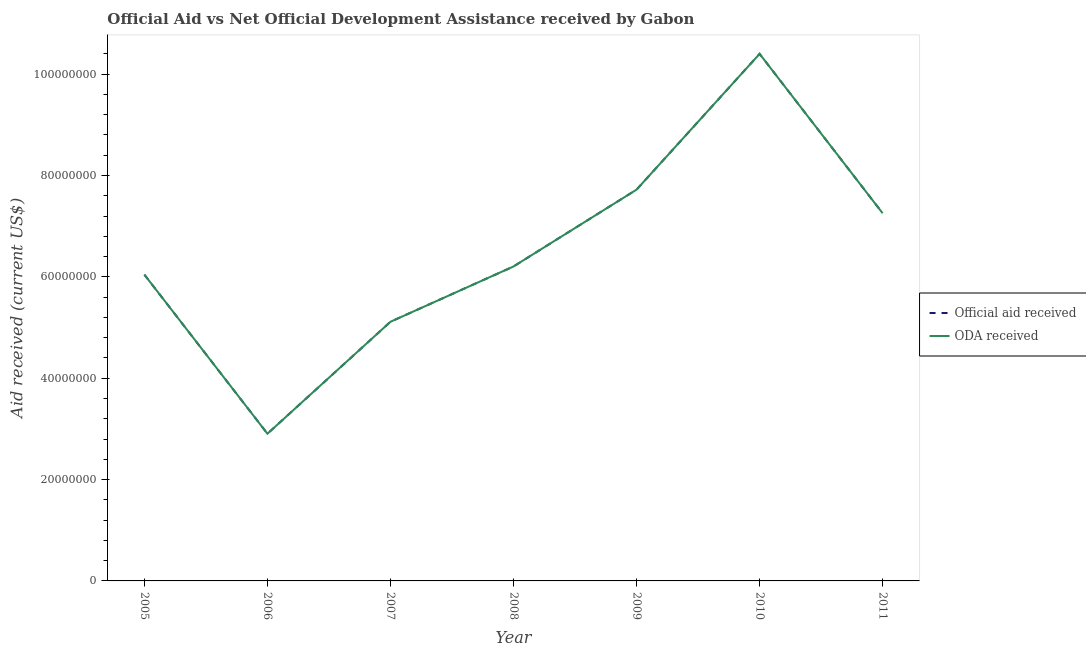How many different coloured lines are there?
Your answer should be compact. 2. Is the number of lines equal to the number of legend labels?
Your response must be concise. Yes. What is the oda received in 2006?
Make the answer very short. 2.90e+07. Across all years, what is the maximum official aid received?
Your answer should be very brief. 1.04e+08. Across all years, what is the minimum oda received?
Provide a succinct answer. 2.90e+07. What is the total oda received in the graph?
Keep it short and to the point. 4.56e+08. What is the difference between the oda received in 2006 and that in 2010?
Provide a short and direct response. -7.50e+07. What is the difference between the official aid received in 2010 and the oda received in 2008?
Your answer should be very brief. 4.20e+07. What is the average oda received per year?
Your answer should be compact. 6.52e+07. In the year 2005, what is the difference between the oda received and official aid received?
Ensure brevity in your answer.  0. In how many years, is the oda received greater than 32000000 US$?
Your answer should be compact. 6. What is the ratio of the oda received in 2005 to that in 2007?
Provide a short and direct response. 1.18. What is the difference between the highest and the second highest oda received?
Your answer should be compact. 2.68e+07. What is the difference between the highest and the lowest oda received?
Give a very brief answer. 7.50e+07. In how many years, is the official aid received greater than the average official aid received taken over all years?
Your answer should be very brief. 3. Is the official aid received strictly greater than the oda received over the years?
Your response must be concise. No. Is the official aid received strictly less than the oda received over the years?
Offer a very short reply. No. How many years are there in the graph?
Offer a terse response. 7. Are the values on the major ticks of Y-axis written in scientific E-notation?
Ensure brevity in your answer.  No. Does the graph contain any zero values?
Keep it short and to the point. No. How are the legend labels stacked?
Your response must be concise. Vertical. What is the title of the graph?
Provide a short and direct response. Official Aid vs Net Official Development Assistance received by Gabon . What is the label or title of the X-axis?
Your response must be concise. Year. What is the label or title of the Y-axis?
Provide a short and direct response. Aid received (current US$). What is the Aid received (current US$) in Official aid received in 2005?
Offer a very short reply. 6.04e+07. What is the Aid received (current US$) of ODA received in 2005?
Provide a short and direct response. 6.04e+07. What is the Aid received (current US$) of Official aid received in 2006?
Give a very brief answer. 2.90e+07. What is the Aid received (current US$) of ODA received in 2006?
Make the answer very short. 2.90e+07. What is the Aid received (current US$) of Official aid received in 2007?
Keep it short and to the point. 5.11e+07. What is the Aid received (current US$) of ODA received in 2007?
Offer a terse response. 5.11e+07. What is the Aid received (current US$) in Official aid received in 2008?
Ensure brevity in your answer.  6.20e+07. What is the Aid received (current US$) in ODA received in 2008?
Your response must be concise. 6.20e+07. What is the Aid received (current US$) of Official aid received in 2009?
Give a very brief answer. 7.72e+07. What is the Aid received (current US$) in ODA received in 2009?
Ensure brevity in your answer.  7.72e+07. What is the Aid received (current US$) of Official aid received in 2010?
Ensure brevity in your answer.  1.04e+08. What is the Aid received (current US$) in ODA received in 2010?
Provide a succinct answer. 1.04e+08. What is the Aid received (current US$) of Official aid received in 2011?
Provide a short and direct response. 7.26e+07. What is the Aid received (current US$) of ODA received in 2011?
Offer a very short reply. 7.26e+07. Across all years, what is the maximum Aid received (current US$) in Official aid received?
Offer a very short reply. 1.04e+08. Across all years, what is the maximum Aid received (current US$) of ODA received?
Your answer should be very brief. 1.04e+08. Across all years, what is the minimum Aid received (current US$) of Official aid received?
Offer a terse response. 2.90e+07. Across all years, what is the minimum Aid received (current US$) in ODA received?
Your answer should be very brief. 2.90e+07. What is the total Aid received (current US$) of Official aid received in the graph?
Your answer should be compact. 4.56e+08. What is the total Aid received (current US$) in ODA received in the graph?
Offer a very short reply. 4.56e+08. What is the difference between the Aid received (current US$) in Official aid received in 2005 and that in 2006?
Provide a short and direct response. 3.14e+07. What is the difference between the Aid received (current US$) in ODA received in 2005 and that in 2006?
Your answer should be compact. 3.14e+07. What is the difference between the Aid received (current US$) in Official aid received in 2005 and that in 2007?
Offer a terse response. 9.29e+06. What is the difference between the Aid received (current US$) in ODA received in 2005 and that in 2007?
Ensure brevity in your answer.  9.29e+06. What is the difference between the Aid received (current US$) of Official aid received in 2005 and that in 2008?
Your answer should be compact. -1.62e+06. What is the difference between the Aid received (current US$) in ODA received in 2005 and that in 2008?
Offer a very short reply. -1.62e+06. What is the difference between the Aid received (current US$) of Official aid received in 2005 and that in 2009?
Provide a short and direct response. -1.68e+07. What is the difference between the Aid received (current US$) in ODA received in 2005 and that in 2009?
Provide a succinct answer. -1.68e+07. What is the difference between the Aid received (current US$) in Official aid received in 2005 and that in 2010?
Provide a succinct answer. -4.36e+07. What is the difference between the Aid received (current US$) in ODA received in 2005 and that in 2010?
Keep it short and to the point. -4.36e+07. What is the difference between the Aid received (current US$) of Official aid received in 2005 and that in 2011?
Keep it short and to the point. -1.21e+07. What is the difference between the Aid received (current US$) in ODA received in 2005 and that in 2011?
Ensure brevity in your answer.  -1.21e+07. What is the difference between the Aid received (current US$) of Official aid received in 2006 and that in 2007?
Keep it short and to the point. -2.21e+07. What is the difference between the Aid received (current US$) in ODA received in 2006 and that in 2007?
Offer a terse response. -2.21e+07. What is the difference between the Aid received (current US$) of Official aid received in 2006 and that in 2008?
Ensure brevity in your answer.  -3.30e+07. What is the difference between the Aid received (current US$) of ODA received in 2006 and that in 2008?
Make the answer very short. -3.30e+07. What is the difference between the Aid received (current US$) of Official aid received in 2006 and that in 2009?
Your answer should be very brief. -4.82e+07. What is the difference between the Aid received (current US$) of ODA received in 2006 and that in 2009?
Ensure brevity in your answer.  -4.82e+07. What is the difference between the Aid received (current US$) of Official aid received in 2006 and that in 2010?
Your answer should be very brief. -7.50e+07. What is the difference between the Aid received (current US$) in ODA received in 2006 and that in 2010?
Give a very brief answer. -7.50e+07. What is the difference between the Aid received (current US$) in Official aid received in 2006 and that in 2011?
Give a very brief answer. -4.35e+07. What is the difference between the Aid received (current US$) of ODA received in 2006 and that in 2011?
Give a very brief answer. -4.35e+07. What is the difference between the Aid received (current US$) in Official aid received in 2007 and that in 2008?
Make the answer very short. -1.09e+07. What is the difference between the Aid received (current US$) in ODA received in 2007 and that in 2008?
Offer a terse response. -1.09e+07. What is the difference between the Aid received (current US$) in Official aid received in 2007 and that in 2009?
Keep it short and to the point. -2.61e+07. What is the difference between the Aid received (current US$) in ODA received in 2007 and that in 2009?
Your response must be concise. -2.61e+07. What is the difference between the Aid received (current US$) in Official aid received in 2007 and that in 2010?
Offer a very short reply. -5.29e+07. What is the difference between the Aid received (current US$) of ODA received in 2007 and that in 2010?
Make the answer very short. -5.29e+07. What is the difference between the Aid received (current US$) in Official aid received in 2007 and that in 2011?
Give a very brief answer. -2.14e+07. What is the difference between the Aid received (current US$) of ODA received in 2007 and that in 2011?
Make the answer very short. -2.14e+07. What is the difference between the Aid received (current US$) in Official aid received in 2008 and that in 2009?
Provide a short and direct response. -1.52e+07. What is the difference between the Aid received (current US$) of ODA received in 2008 and that in 2009?
Provide a short and direct response. -1.52e+07. What is the difference between the Aid received (current US$) of Official aid received in 2008 and that in 2010?
Offer a very short reply. -4.20e+07. What is the difference between the Aid received (current US$) of ODA received in 2008 and that in 2010?
Your answer should be compact. -4.20e+07. What is the difference between the Aid received (current US$) of Official aid received in 2008 and that in 2011?
Your answer should be very brief. -1.05e+07. What is the difference between the Aid received (current US$) in ODA received in 2008 and that in 2011?
Offer a terse response. -1.05e+07. What is the difference between the Aid received (current US$) in Official aid received in 2009 and that in 2010?
Ensure brevity in your answer.  -2.68e+07. What is the difference between the Aid received (current US$) in ODA received in 2009 and that in 2010?
Ensure brevity in your answer.  -2.68e+07. What is the difference between the Aid received (current US$) of Official aid received in 2009 and that in 2011?
Keep it short and to the point. 4.66e+06. What is the difference between the Aid received (current US$) in ODA received in 2009 and that in 2011?
Ensure brevity in your answer.  4.66e+06. What is the difference between the Aid received (current US$) in Official aid received in 2010 and that in 2011?
Offer a terse response. 3.14e+07. What is the difference between the Aid received (current US$) in ODA received in 2010 and that in 2011?
Provide a succinct answer. 3.14e+07. What is the difference between the Aid received (current US$) of Official aid received in 2005 and the Aid received (current US$) of ODA received in 2006?
Your answer should be compact. 3.14e+07. What is the difference between the Aid received (current US$) in Official aid received in 2005 and the Aid received (current US$) in ODA received in 2007?
Your answer should be very brief. 9.29e+06. What is the difference between the Aid received (current US$) of Official aid received in 2005 and the Aid received (current US$) of ODA received in 2008?
Ensure brevity in your answer.  -1.62e+06. What is the difference between the Aid received (current US$) of Official aid received in 2005 and the Aid received (current US$) of ODA received in 2009?
Your answer should be very brief. -1.68e+07. What is the difference between the Aid received (current US$) in Official aid received in 2005 and the Aid received (current US$) in ODA received in 2010?
Make the answer very short. -4.36e+07. What is the difference between the Aid received (current US$) of Official aid received in 2005 and the Aid received (current US$) of ODA received in 2011?
Your response must be concise. -1.21e+07. What is the difference between the Aid received (current US$) of Official aid received in 2006 and the Aid received (current US$) of ODA received in 2007?
Make the answer very short. -2.21e+07. What is the difference between the Aid received (current US$) of Official aid received in 2006 and the Aid received (current US$) of ODA received in 2008?
Your response must be concise. -3.30e+07. What is the difference between the Aid received (current US$) of Official aid received in 2006 and the Aid received (current US$) of ODA received in 2009?
Offer a very short reply. -4.82e+07. What is the difference between the Aid received (current US$) of Official aid received in 2006 and the Aid received (current US$) of ODA received in 2010?
Make the answer very short. -7.50e+07. What is the difference between the Aid received (current US$) in Official aid received in 2006 and the Aid received (current US$) in ODA received in 2011?
Offer a terse response. -4.35e+07. What is the difference between the Aid received (current US$) in Official aid received in 2007 and the Aid received (current US$) in ODA received in 2008?
Give a very brief answer. -1.09e+07. What is the difference between the Aid received (current US$) in Official aid received in 2007 and the Aid received (current US$) in ODA received in 2009?
Provide a succinct answer. -2.61e+07. What is the difference between the Aid received (current US$) in Official aid received in 2007 and the Aid received (current US$) in ODA received in 2010?
Your answer should be compact. -5.29e+07. What is the difference between the Aid received (current US$) of Official aid received in 2007 and the Aid received (current US$) of ODA received in 2011?
Provide a short and direct response. -2.14e+07. What is the difference between the Aid received (current US$) in Official aid received in 2008 and the Aid received (current US$) in ODA received in 2009?
Ensure brevity in your answer.  -1.52e+07. What is the difference between the Aid received (current US$) of Official aid received in 2008 and the Aid received (current US$) of ODA received in 2010?
Offer a very short reply. -4.20e+07. What is the difference between the Aid received (current US$) in Official aid received in 2008 and the Aid received (current US$) in ODA received in 2011?
Offer a terse response. -1.05e+07. What is the difference between the Aid received (current US$) in Official aid received in 2009 and the Aid received (current US$) in ODA received in 2010?
Provide a succinct answer. -2.68e+07. What is the difference between the Aid received (current US$) of Official aid received in 2009 and the Aid received (current US$) of ODA received in 2011?
Offer a very short reply. 4.66e+06. What is the difference between the Aid received (current US$) in Official aid received in 2010 and the Aid received (current US$) in ODA received in 2011?
Your answer should be compact. 3.14e+07. What is the average Aid received (current US$) in Official aid received per year?
Your response must be concise. 6.52e+07. What is the average Aid received (current US$) of ODA received per year?
Keep it short and to the point. 6.52e+07. In the year 2011, what is the difference between the Aid received (current US$) in Official aid received and Aid received (current US$) in ODA received?
Ensure brevity in your answer.  0. What is the ratio of the Aid received (current US$) of Official aid received in 2005 to that in 2006?
Ensure brevity in your answer.  2.08. What is the ratio of the Aid received (current US$) in ODA received in 2005 to that in 2006?
Your answer should be very brief. 2.08. What is the ratio of the Aid received (current US$) of Official aid received in 2005 to that in 2007?
Make the answer very short. 1.18. What is the ratio of the Aid received (current US$) in ODA received in 2005 to that in 2007?
Provide a short and direct response. 1.18. What is the ratio of the Aid received (current US$) in Official aid received in 2005 to that in 2008?
Your answer should be compact. 0.97. What is the ratio of the Aid received (current US$) in ODA received in 2005 to that in 2008?
Your answer should be very brief. 0.97. What is the ratio of the Aid received (current US$) of Official aid received in 2005 to that in 2009?
Make the answer very short. 0.78. What is the ratio of the Aid received (current US$) of ODA received in 2005 to that in 2009?
Your answer should be very brief. 0.78. What is the ratio of the Aid received (current US$) in Official aid received in 2005 to that in 2010?
Offer a terse response. 0.58. What is the ratio of the Aid received (current US$) in ODA received in 2005 to that in 2010?
Keep it short and to the point. 0.58. What is the ratio of the Aid received (current US$) of Official aid received in 2005 to that in 2011?
Offer a very short reply. 0.83. What is the ratio of the Aid received (current US$) in ODA received in 2005 to that in 2011?
Keep it short and to the point. 0.83. What is the ratio of the Aid received (current US$) in Official aid received in 2006 to that in 2007?
Your answer should be very brief. 0.57. What is the ratio of the Aid received (current US$) in ODA received in 2006 to that in 2007?
Your answer should be very brief. 0.57. What is the ratio of the Aid received (current US$) of Official aid received in 2006 to that in 2008?
Offer a very short reply. 0.47. What is the ratio of the Aid received (current US$) in ODA received in 2006 to that in 2008?
Offer a very short reply. 0.47. What is the ratio of the Aid received (current US$) of Official aid received in 2006 to that in 2009?
Offer a very short reply. 0.38. What is the ratio of the Aid received (current US$) of ODA received in 2006 to that in 2009?
Ensure brevity in your answer.  0.38. What is the ratio of the Aid received (current US$) in Official aid received in 2006 to that in 2010?
Your answer should be compact. 0.28. What is the ratio of the Aid received (current US$) of ODA received in 2006 to that in 2010?
Your response must be concise. 0.28. What is the ratio of the Aid received (current US$) of Official aid received in 2006 to that in 2011?
Give a very brief answer. 0.4. What is the ratio of the Aid received (current US$) of ODA received in 2006 to that in 2011?
Provide a succinct answer. 0.4. What is the ratio of the Aid received (current US$) in Official aid received in 2007 to that in 2008?
Make the answer very short. 0.82. What is the ratio of the Aid received (current US$) of ODA received in 2007 to that in 2008?
Provide a short and direct response. 0.82. What is the ratio of the Aid received (current US$) in Official aid received in 2007 to that in 2009?
Offer a very short reply. 0.66. What is the ratio of the Aid received (current US$) in ODA received in 2007 to that in 2009?
Provide a short and direct response. 0.66. What is the ratio of the Aid received (current US$) in Official aid received in 2007 to that in 2010?
Keep it short and to the point. 0.49. What is the ratio of the Aid received (current US$) of ODA received in 2007 to that in 2010?
Your answer should be very brief. 0.49. What is the ratio of the Aid received (current US$) of Official aid received in 2007 to that in 2011?
Keep it short and to the point. 0.7. What is the ratio of the Aid received (current US$) of ODA received in 2007 to that in 2011?
Keep it short and to the point. 0.7. What is the ratio of the Aid received (current US$) of Official aid received in 2008 to that in 2009?
Ensure brevity in your answer.  0.8. What is the ratio of the Aid received (current US$) in ODA received in 2008 to that in 2009?
Your answer should be very brief. 0.8. What is the ratio of the Aid received (current US$) in Official aid received in 2008 to that in 2010?
Your answer should be very brief. 0.6. What is the ratio of the Aid received (current US$) in ODA received in 2008 to that in 2010?
Make the answer very short. 0.6. What is the ratio of the Aid received (current US$) in Official aid received in 2008 to that in 2011?
Your answer should be very brief. 0.86. What is the ratio of the Aid received (current US$) of ODA received in 2008 to that in 2011?
Make the answer very short. 0.86. What is the ratio of the Aid received (current US$) in Official aid received in 2009 to that in 2010?
Ensure brevity in your answer.  0.74. What is the ratio of the Aid received (current US$) of ODA received in 2009 to that in 2010?
Your answer should be very brief. 0.74. What is the ratio of the Aid received (current US$) in Official aid received in 2009 to that in 2011?
Your response must be concise. 1.06. What is the ratio of the Aid received (current US$) of ODA received in 2009 to that in 2011?
Provide a succinct answer. 1.06. What is the ratio of the Aid received (current US$) in Official aid received in 2010 to that in 2011?
Offer a terse response. 1.43. What is the ratio of the Aid received (current US$) of ODA received in 2010 to that in 2011?
Ensure brevity in your answer.  1.43. What is the difference between the highest and the second highest Aid received (current US$) in Official aid received?
Offer a very short reply. 2.68e+07. What is the difference between the highest and the second highest Aid received (current US$) of ODA received?
Your answer should be compact. 2.68e+07. What is the difference between the highest and the lowest Aid received (current US$) of Official aid received?
Your answer should be compact. 7.50e+07. What is the difference between the highest and the lowest Aid received (current US$) in ODA received?
Provide a short and direct response. 7.50e+07. 